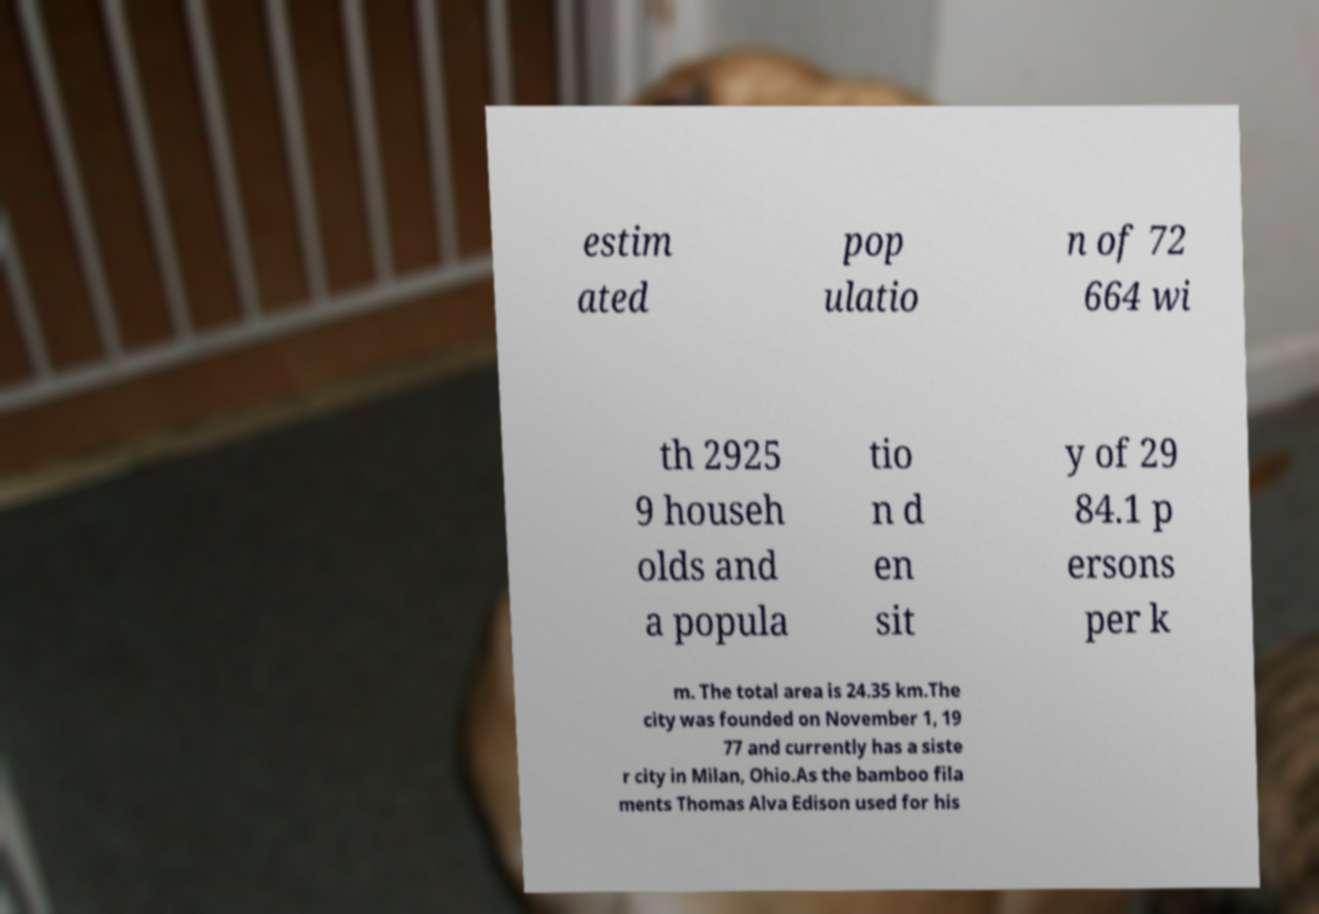Can you read and provide the text displayed in the image?This photo seems to have some interesting text. Can you extract and type it out for me? estim ated pop ulatio n of 72 664 wi th 2925 9 househ olds and a popula tio n d en sit y of 29 84.1 p ersons per k m. The total area is 24.35 km.The city was founded on November 1, 19 77 and currently has a siste r city in Milan, Ohio.As the bamboo fila ments Thomas Alva Edison used for his 